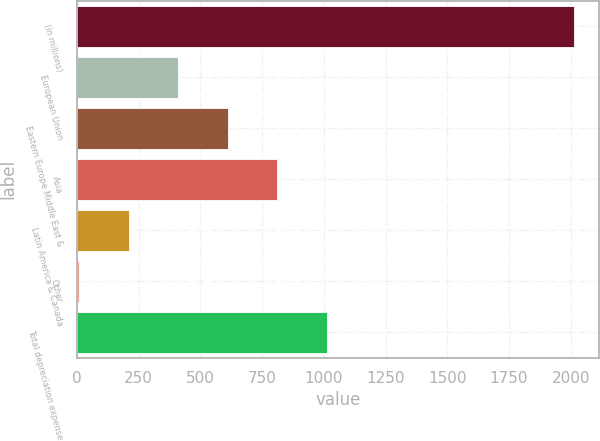Convert chart. <chart><loc_0><loc_0><loc_500><loc_500><bar_chart><fcel>(in millions)<fcel>European Union<fcel>Eastern Europe Middle East &<fcel>Asia<fcel>Latin America & Canada<fcel>Other<fcel>Total depreciation expense<nl><fcel>2014<fcel>410.8<fcel>611.2<fcel>811.6<fcel>210.4<fcel>10<fcel>1012<nl></chart> 